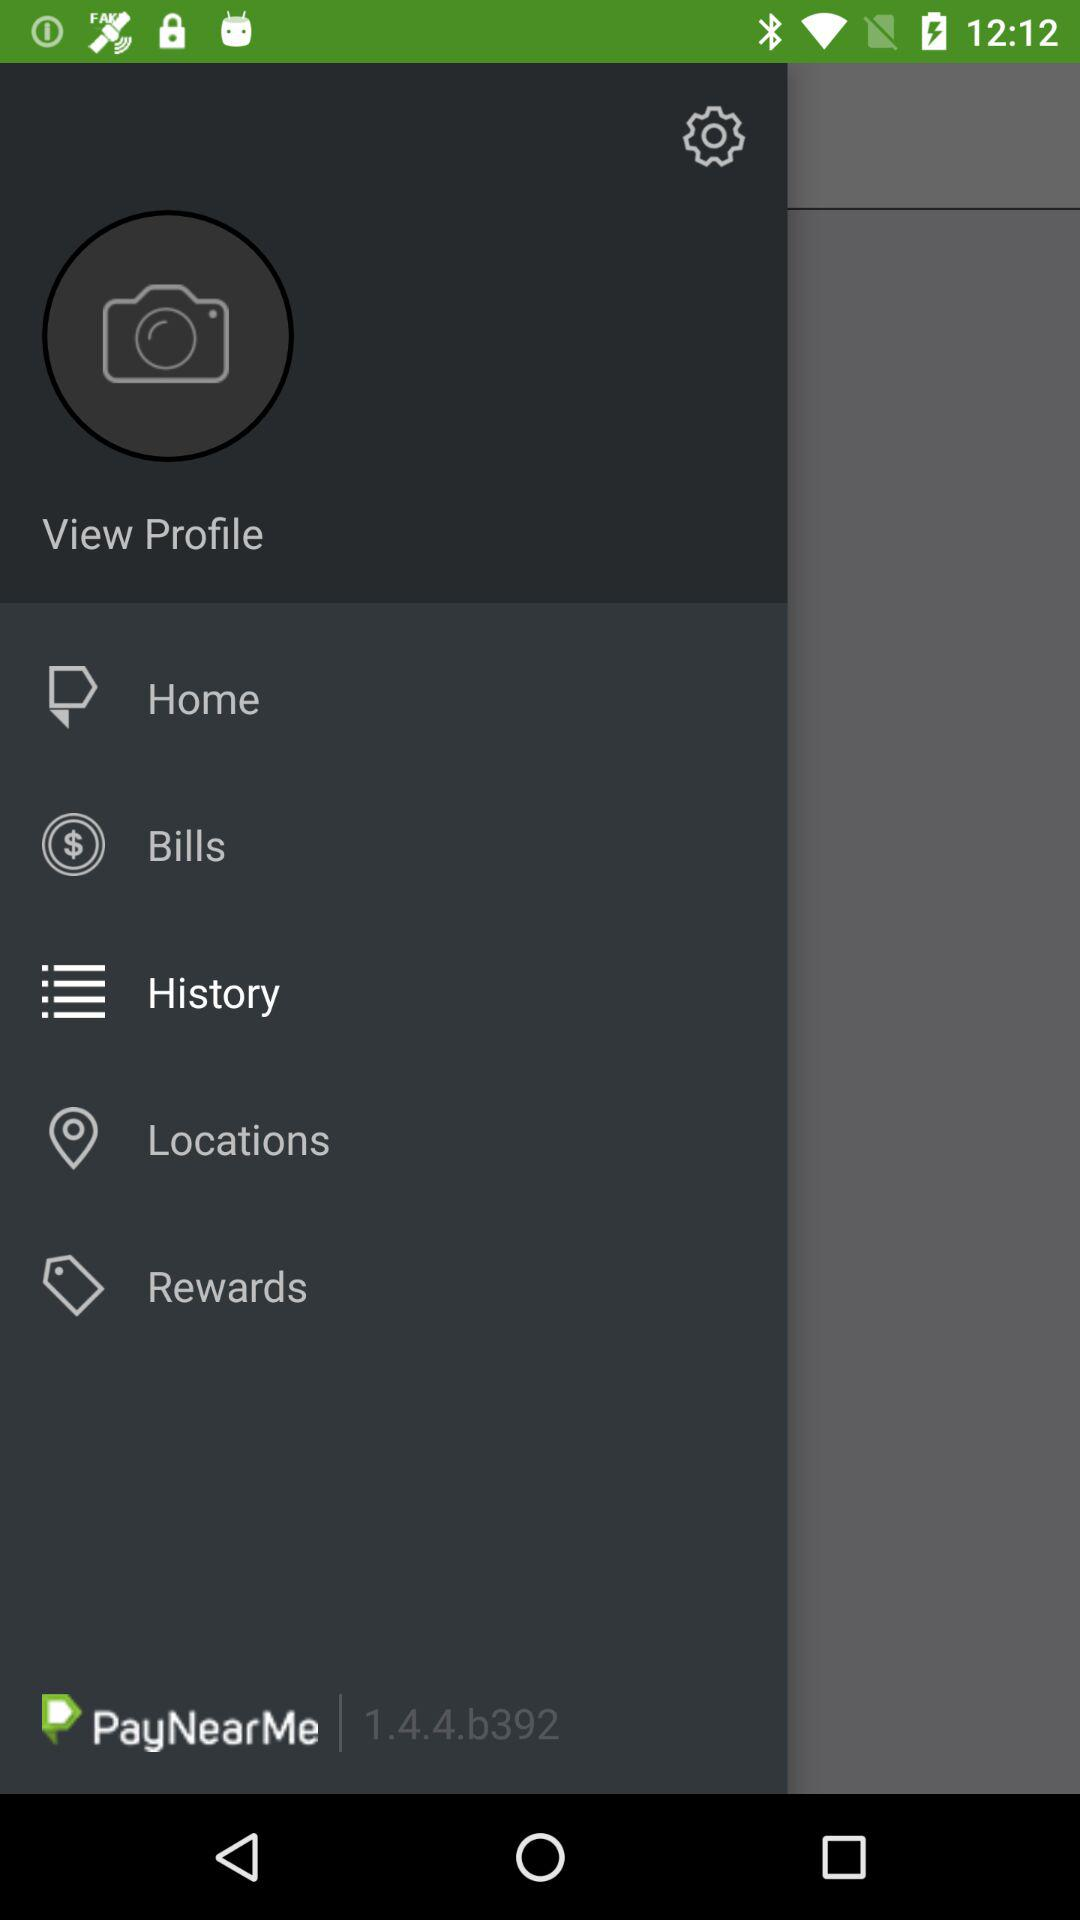What is the version of "PayNearMe"? The version is 1.4.4.6392. 